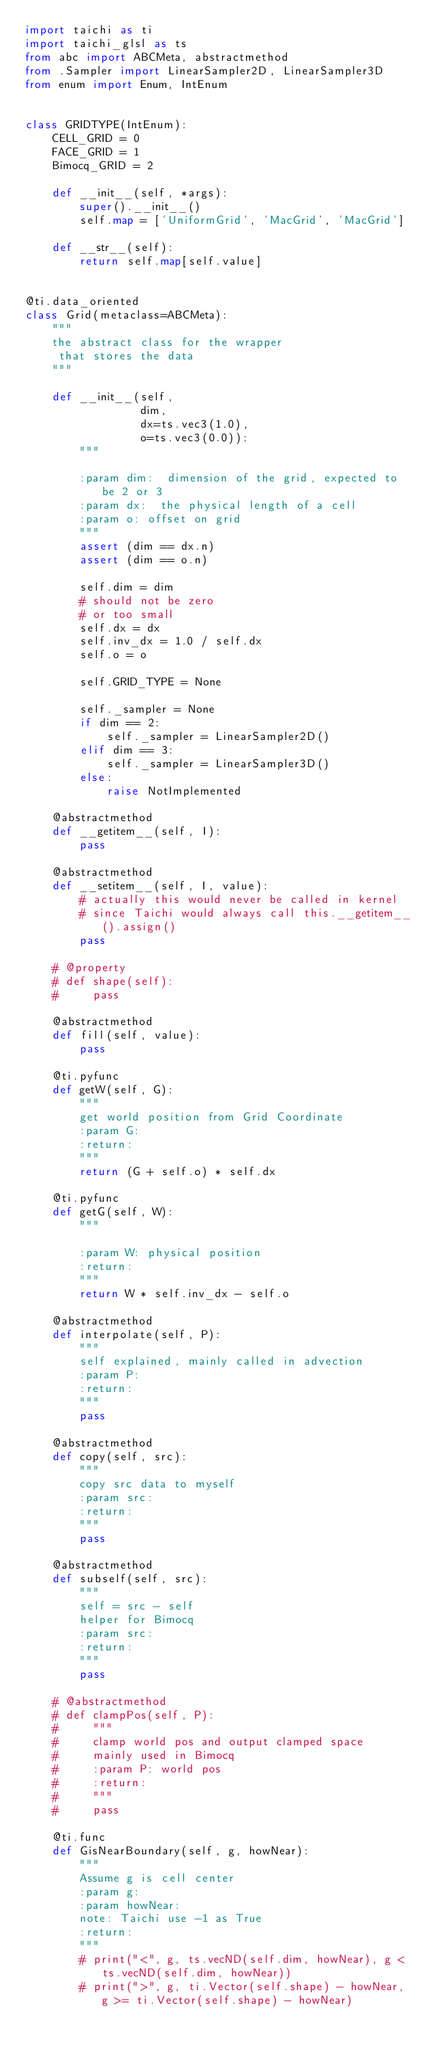Convert code to text. <code><loc_0><loc_0><loc_500><loc_500><_Python_>import taichi as ti
import taichi_glsl as ts
from abc import ABCMeta, abstractmethod
from .Sampler import LinearSampler2D, LinearSampler3D
from enum import Enum, IntEnum


class GRIDTYPE(IntEnum):
    CELL_GRID = 0
    FACE_GRID = 1
    Bimocq_GRID = 2

    def __init__(self, *args):
        super().__init__()
        self.map = ['UniformGrid', 'MacGrid', 'MacGrid']

    def __str__(self):
        return self.map[self.value]


@ti.data_oriented
class Grid(metaclass=ABCMeta):
    """
    the abstract class for the wrapper
     that stores the data
    """

    def __init__(self,
                 dim,
                 dx=ts.vec3(1.0),
                 o=ts.vec3(0.0)):
        """

        :param dim:  dimension of the grid, expected to be 2 or 3
        :param dx:  the physical length of a cell
        :param o: offset on grid
        """
        assert (dim == dx.n)
        assert (dim == o.n)

        self.dim = dim
        # should not be zero
        # or too small
        self.dx = dx
        self.inv_dx = 1.0 / self.dx
        self.o = o

        self.GRID_TYPE = None

        self._sampler = None
        if dim == 2:
            self._sampler = LinearSampler2D()
        elif dim == 3:
            self._sampler = LinearSampler3D()
        else:
            raise NotImplemented

    @abstractmethod
    def __getitem__(self, I):
        pass

    @abstractmethod
    def __setitem__(self, I, value):
        # actually this would never be called in kernel
        # since Taichi would always call this.__getitem__().assign()
        pass

    # @property
    # def shape(self):
    #     pass

    @abstractmethod
    def fill(self, value):
        pass

    @ti.pyfunc
    def getW(self, G):
        """
        get world position from Grid Coordinate
        :param G:
        :return:
        """
        return (G + self.o) * self.dx

    @ti.pyfunc
    def getG(self, W):
        """

        :param W: physical position
        :return:
        """
        return W * self.inv_dx - self.o

    @abstractmethod
    def interpolate(self, P):
        """
        self explained, mainly called in advection
        :param P:
        :return:
        """
        pass

    @abstractmethod
    def copy(self, src):
        """
        copy src data to myself
        :param src:
        :return:
        """
        pass

    @abstractmethod
    def subself(self, src):
        """
        self = src - self
        helper for Bimocq
        :param src:
        :return:
        """
        pass

    # @abstractmethod
    # def clampPos(self, P):
    #     """
    #     clamp world pos and output clamped space
    #     mainly used in Bimocq
    #     :param P: world pos
    #     :return:
    #     """
    #     pass

    @ti.func
    def GisNearBoundary(self, g, howNear):
        """
        Assume g is cell center
        :param g:
        :param howNear:
        note: Taichi use -1 as True
        :return:
        """
        # print("<", g, ts.vecND(self.dim, howNear), g < ts.vecND(self.dim, howNear))
        # print(">", g, ti.Vector(self.shape) - howNear, g >= ti.Vector(self.shape) - howNear)</code> 